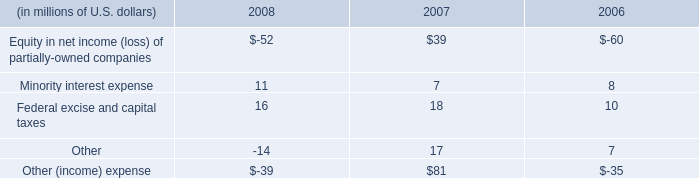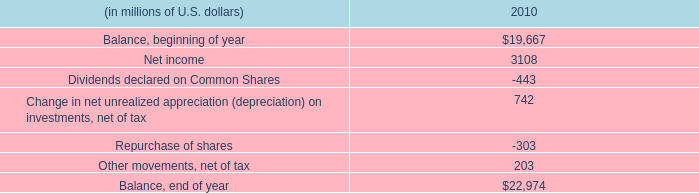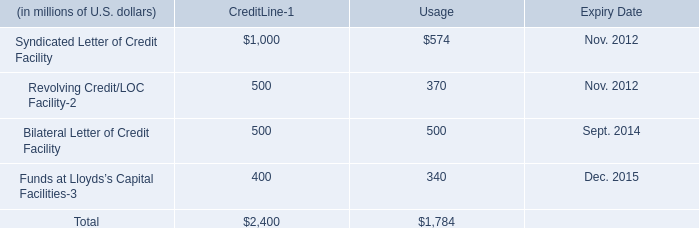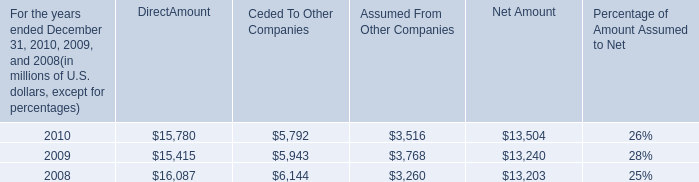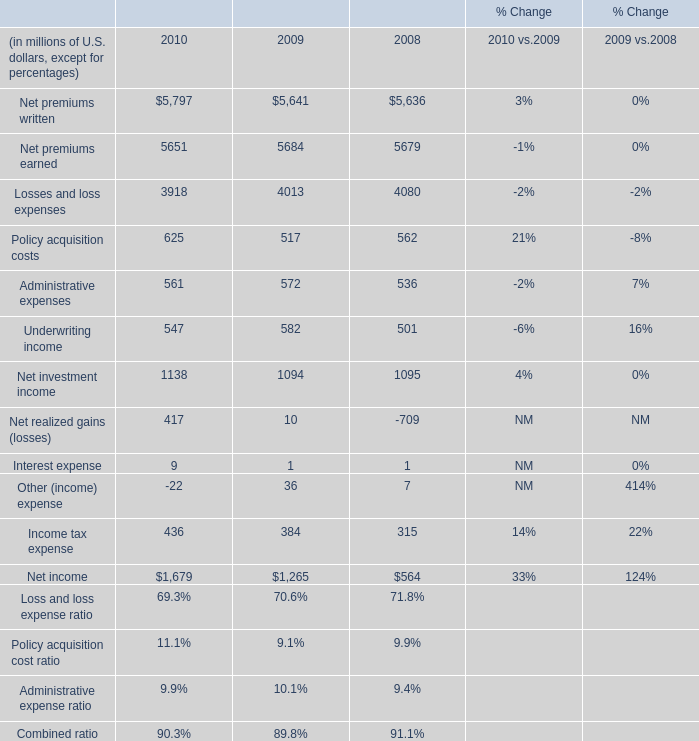What is the sum of the Interest expense in the years where Net realized gains is positive? (in million) 
Computations: (9 + 1)
Answer: 10.0. 